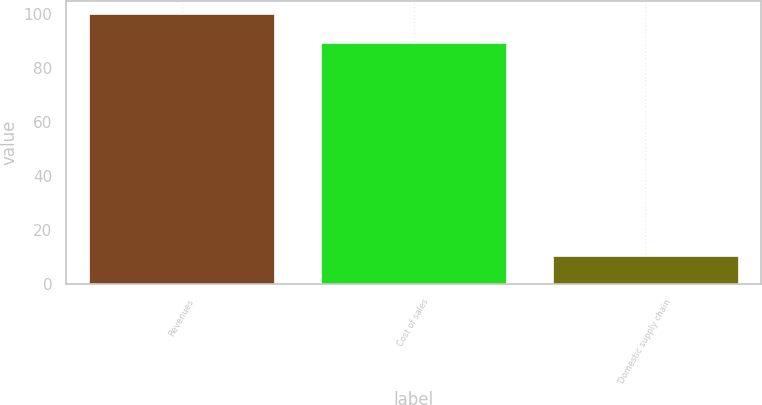Convert chart. <chart><loc_0><loc_0><loc_500><loc_500><bar_chart><fcel>Revenues<fcel>Cost of sales<fcel>Domestic supply chain<nl><fcel>100<fcel>89.6<fcel>10.4<nl></chart> 